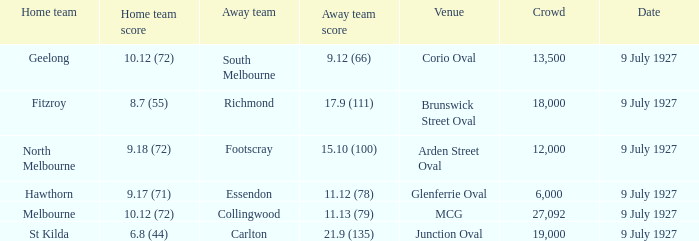Which team was the opponent of the home team north melbourne as the away team? Footscray. 